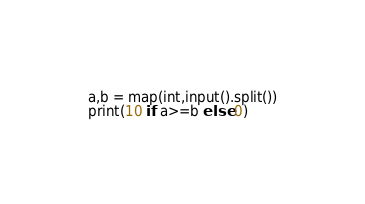<code> <loc_0><loc_0><loc_500><loc_500><_Python_>a,b = map(int,input().split())
print(10 if a>=b else 0)</code> 